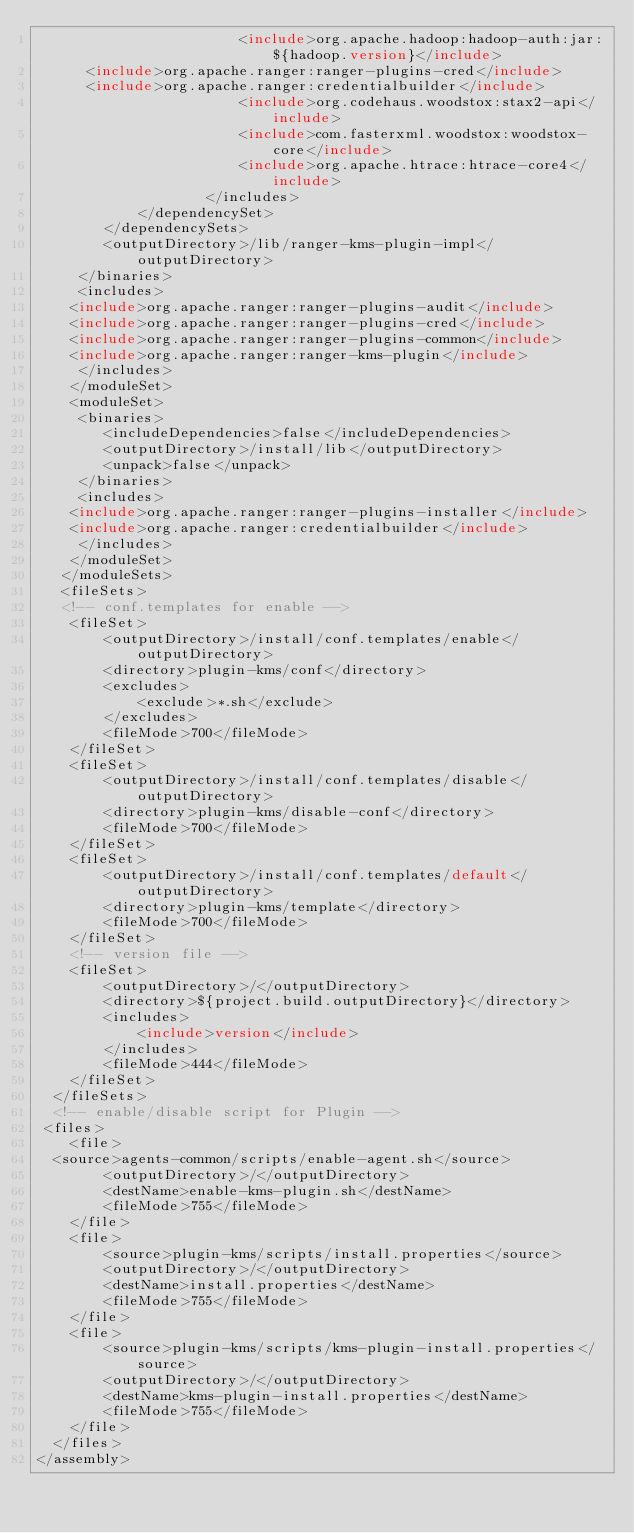<code> <loc_0><loc_0><loc_500><loc_500><_XML_>                        <include>org.apache.hadoop:hadoop-auth:jar:${hadoop.version}</include>
			<include>org.apache.ranger:ranger-plugins-cred</include>
			<include>org.apache.ranger:credentialbuilder</include>
                        <include>org.codehaus.woodstox:stax2-api</include>
                        <include>com.fasterxml.woodstox:woodstox-core</include>
                        <include>org.apache.htrace:htrace-core4</include>
                    </includes>
            </dependencySet>
        </dependencySets>
        <outputDirectory>/lib/ranger-kms-plugin-impl</outputDirectory>
     </binaries>
     <includes>
		<include>org.apache.ranger:ranger-plugins-audit</include>
		<include>org.apache.ranger:ranger-plugins-cred</include>
		<include>org.apache.ranger:ranger-plugins-common</include>
		<include>org.apache.ranger:ranger-kms-plugin</include>
     </includes>
    </moduleSet>
    <moduleSet>
     <binaries>
        <includeDependencies>false</includeDependencies>
        <outputDirectory>/install/lib</outputDirectory>
        <unpack>false</unpack>
     </binaries>
     <includes>
		<include>org.apache.ranger:ranger-plugins-installer</include>
		<include>org.apache.ranger:credentialbuilder</include>
     </includes>
    </moduleSet>
   </moduleSets>
   <fileSets>
   <!-- conf.templates for enable -->
    <fileSet>
        <outputDirectory>/install/conf.templates/enable</outputDirectory>
        <directory>plugin-kms/conf</directory>
        <excludes>
            <exclude>*.sh</exclude>
        </excludes>
        <fileMode>700</fileMode>
    </fileSet>
    <fileSet>
        <outputDirectory>/install/conf.templates/disable</outputDirectory>
        <directory>plugin-kms/disable-conf</directory>
        <fileMode>700</fileMode>
    </fileSet>
    <fileSet>
        <outputDirectory>/install/conf.templates/default</outputDirectory>
        <directory>plugin-kms/template</directory>
        <fileMode>700</fileMode>
    </fileSet>
    <!-- version file -->
    <fileSet>
        <outputDirectory>/</outputDirectory>
        <directory>${project.build.outputDirectory}</directory>
        <includes>
            <include>version</include>
        </includes>
        <fileMode>444</fileMode>
    </fileSet>
  </fileSets>
  <!-- enable/disable script for Plugin -->
 <files>
    <file>
	<source>agents-common/scripts/enable-agent.sh</source>
        <outputDirectory>/</outputDirectory>
        <destName>enable-kms-plugin.sh</destName>
        <fileMode>755</fileMode>
    </file>    
    <file>
        <source>plugin-kms/scripts/install.properties</source>
        <outputDirectory>/</outputDirectory>
        <destName>install.properties</destName>
        <fileMode>755</fileMode>
    </file>
    <file>
        <source>plugin-kms/scripts/kms-plugin-install.properties</source>
        <outputDirectory>/</outputDirectory>
        <destName>kms-plugin-install.properties</destName>
        <fileMode>755</fileMode>
    </file>
  </files>
</assembly>
</code> 